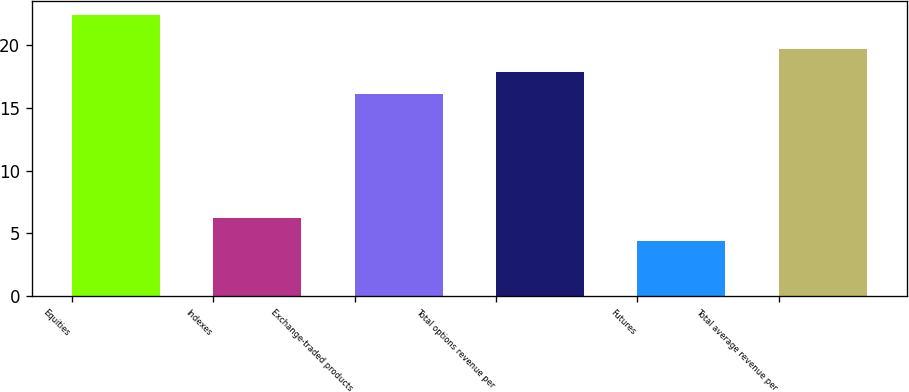Convert chart. <chart><loc_0><loc_0><loc_500><loc_500><bar_chart><fcel>Equities<fcel>Indexes<fcel>Exchange-traded products<fcel>Total options revenue per<fcel>Futures<fcel>Total average revenue per<nl><fcel>22.4<fcel>6.2<fcel>16.1<fcel>17.9<fcel>4.4<fcel>19.7<nl></chart> 